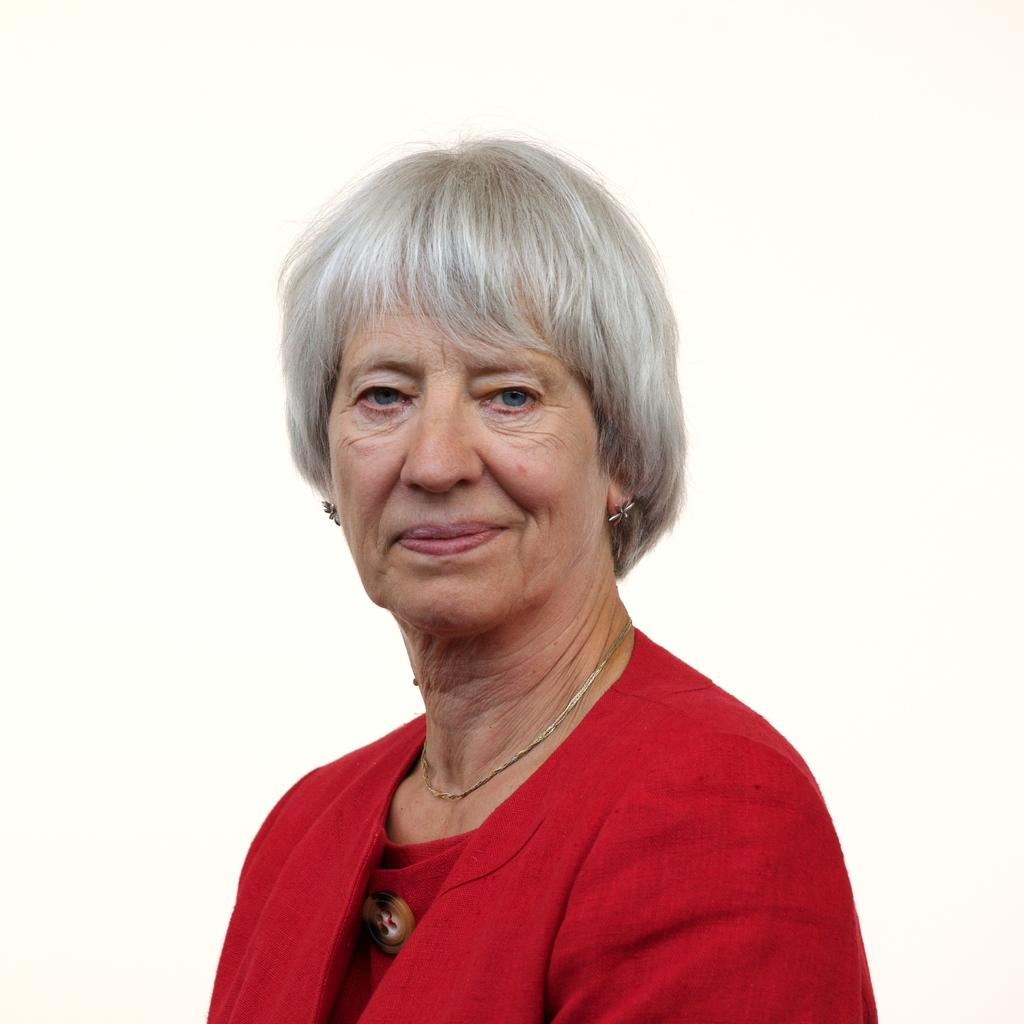Who is the main subject in the foreground of the image? There is a woman in the foreground of the image. What can be observed about the background of the image? The background appears to be white. Can you describe the setting of the image? The image may have been taken in a room, based on the white background. Can you see the woman jumping in the image? There is no indication in the image that the woman is jumping; she is standing still in the foreground. 